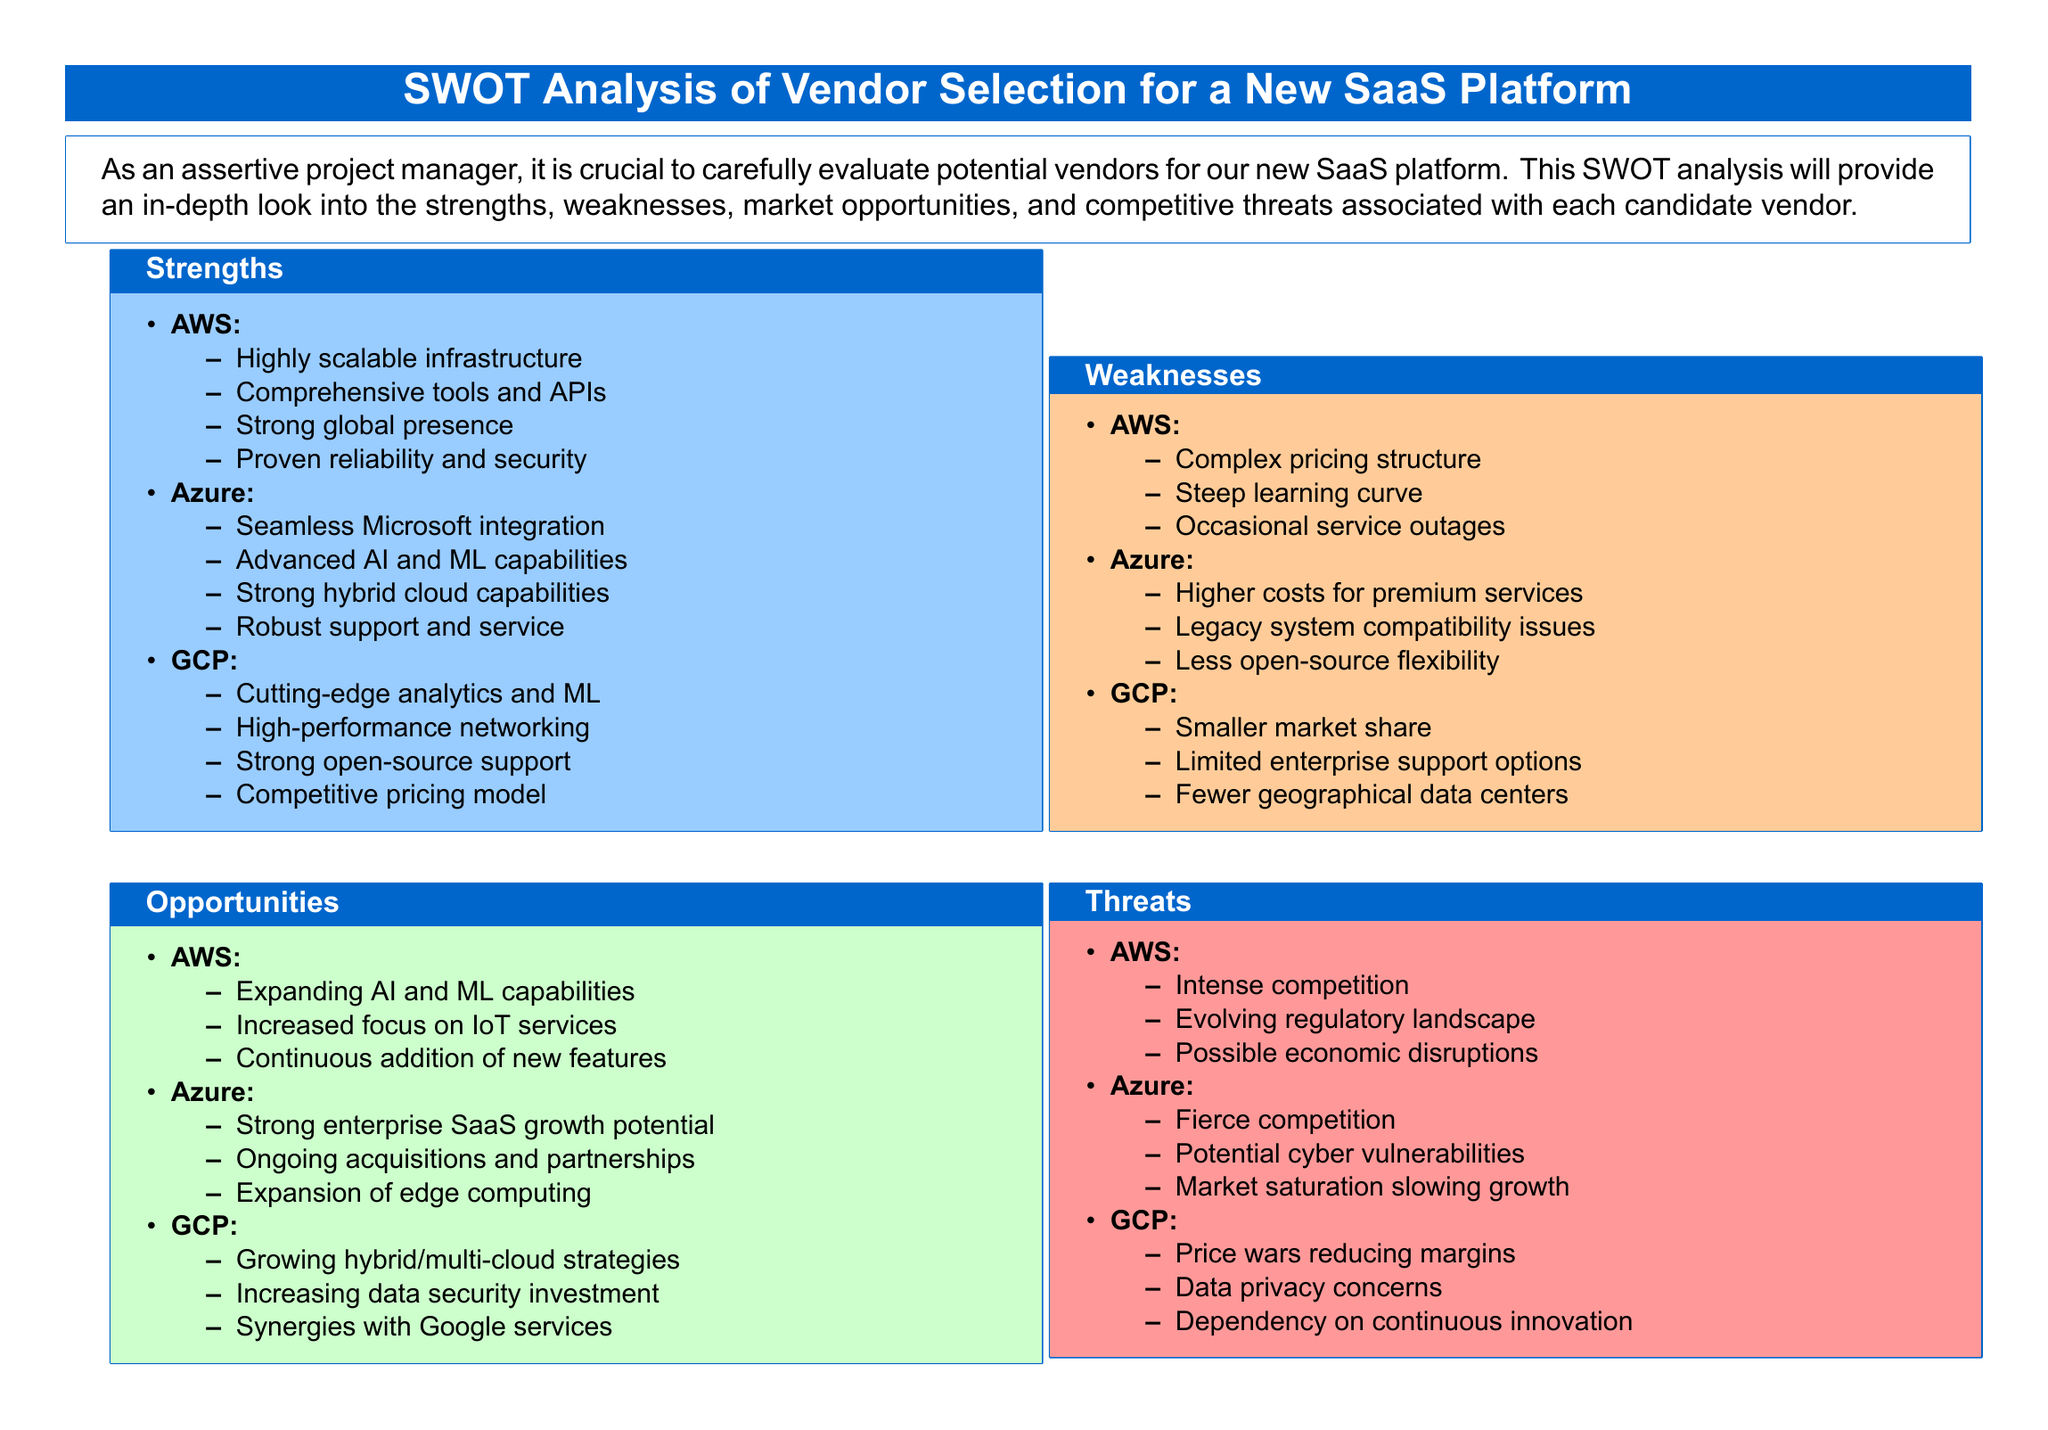What are the strengths of AWS? The strengths of AWS include highly scalable infrastructure, comprehensive tools and APIs, strong global presence, and proven reliability and security.
Answer: Highly scalable infrastructure, comprehensive tools and APIs, strong global presence, proven reliability and security What is a weakness of GCP? A weakness of GCP is its smaller market share, which indicates it has less penetration in the market compared to competitors like AWS and Azure.
Answer: Smaller market share Which vendor has advanced AI and ML capabilities? The document specifies that Azure possesses advanced AI and ML capabilities as one of its strengths.
Answer: Azure What opportunity is listed for AWS? The document describes expanding AI and ML capabilities as a significant opportunity for AWS in the market.
Answer: Expanding AI and ML capabilities What threat does Azure face? According to the document, Azure faces fierce competition as one of its main threats in the market.
Answer: Fierce competition What is the main threat to GCP? The main threat to GCP discussed in the document is price wars reducing margins, which could impact profitability.
Answer: Price wars reducing margins What is one of Azure's weaknesses? The document mentions that higher costs for premium services is one of Azure's weaknesses that could affect customer decision-making.
Answer: Higher costs for premium services What kind of support does GCP have? GCP has limited enterprise support options, which can affect large businesses looking for vendor partnerships.
Answer: Limited enterprise support options What growth potential does Azure have? Azure has strong enterprise SaaS growth potential, which indicates opportunities for expansion in the software sector.
Answer: Strong enterprise SaaS growth potential 